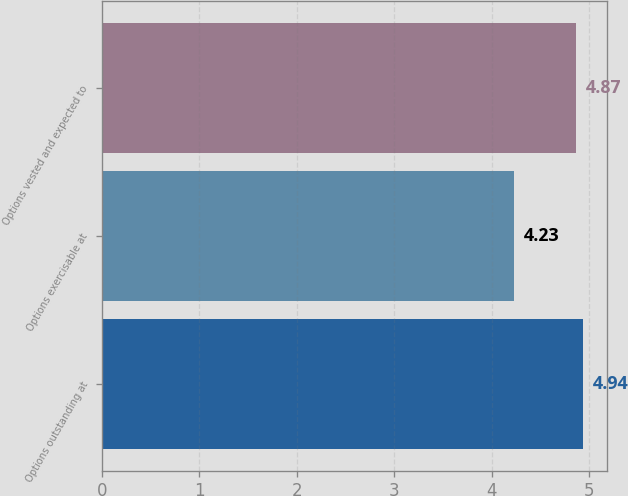Convert chart. <chart><loc_0><loc_0><loc_500><loc_500><bar_chart><fcel>Options outstanding at<fcel>Options exercisable at<fcel>Options vested and expected to<nl><fcel>4.94<fcel>4.23<fcel>4.87<nl></chart> 